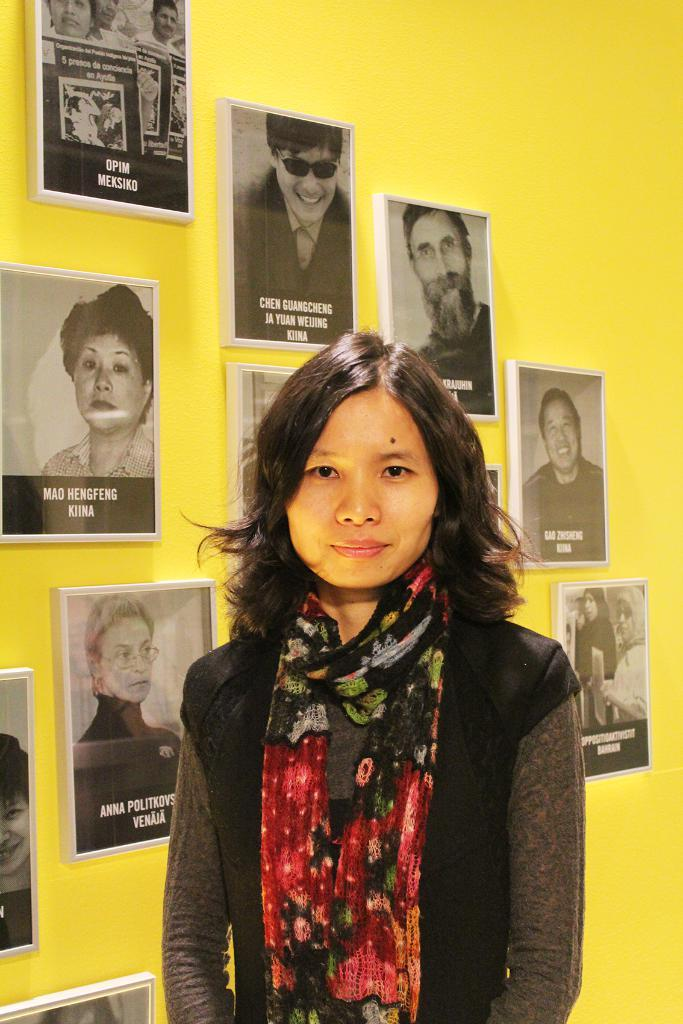What is present in the image? There is a woman in the image. Can you describe the background of the image? There are frames on a yellow color wall in the background of the image. What type of wheel can be seen in the image? There is no wheel present in the image. What type of letter is the woman holding in the image? There is no letter present in the image. 